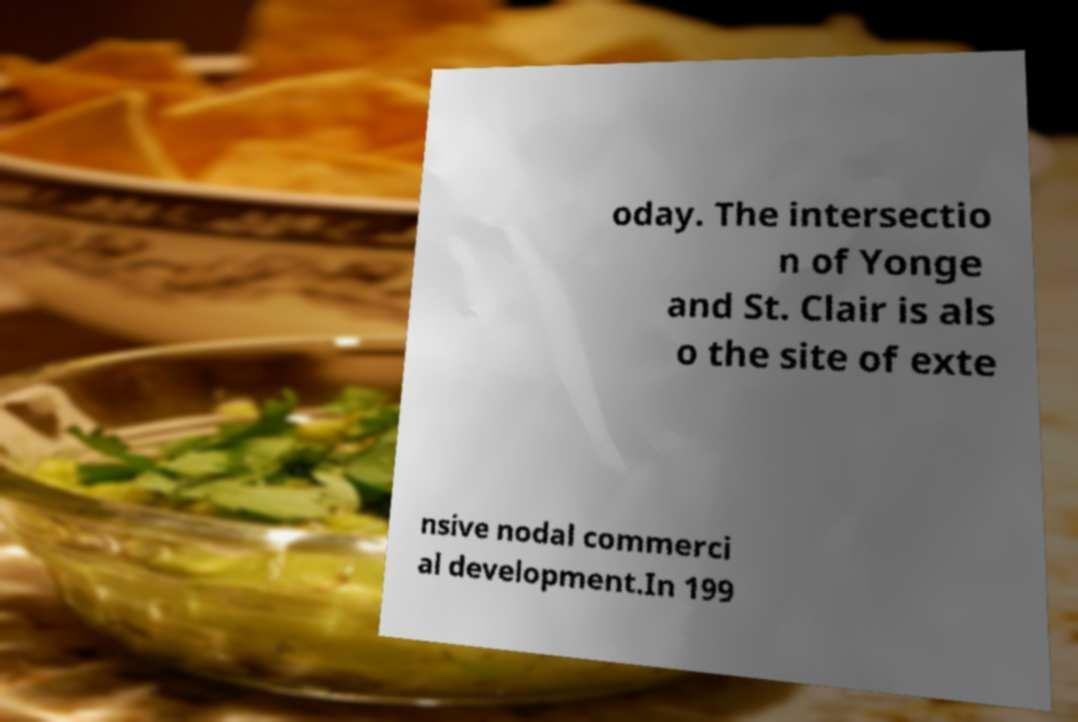Can you read and provide the text displayed in the image?This photo seems to have some interesting text. Can you extract and type it out for me? oday. The intersectio n of Yonge and St. Clair is als o the site of exte nsive nodal commerci al development.In 199 